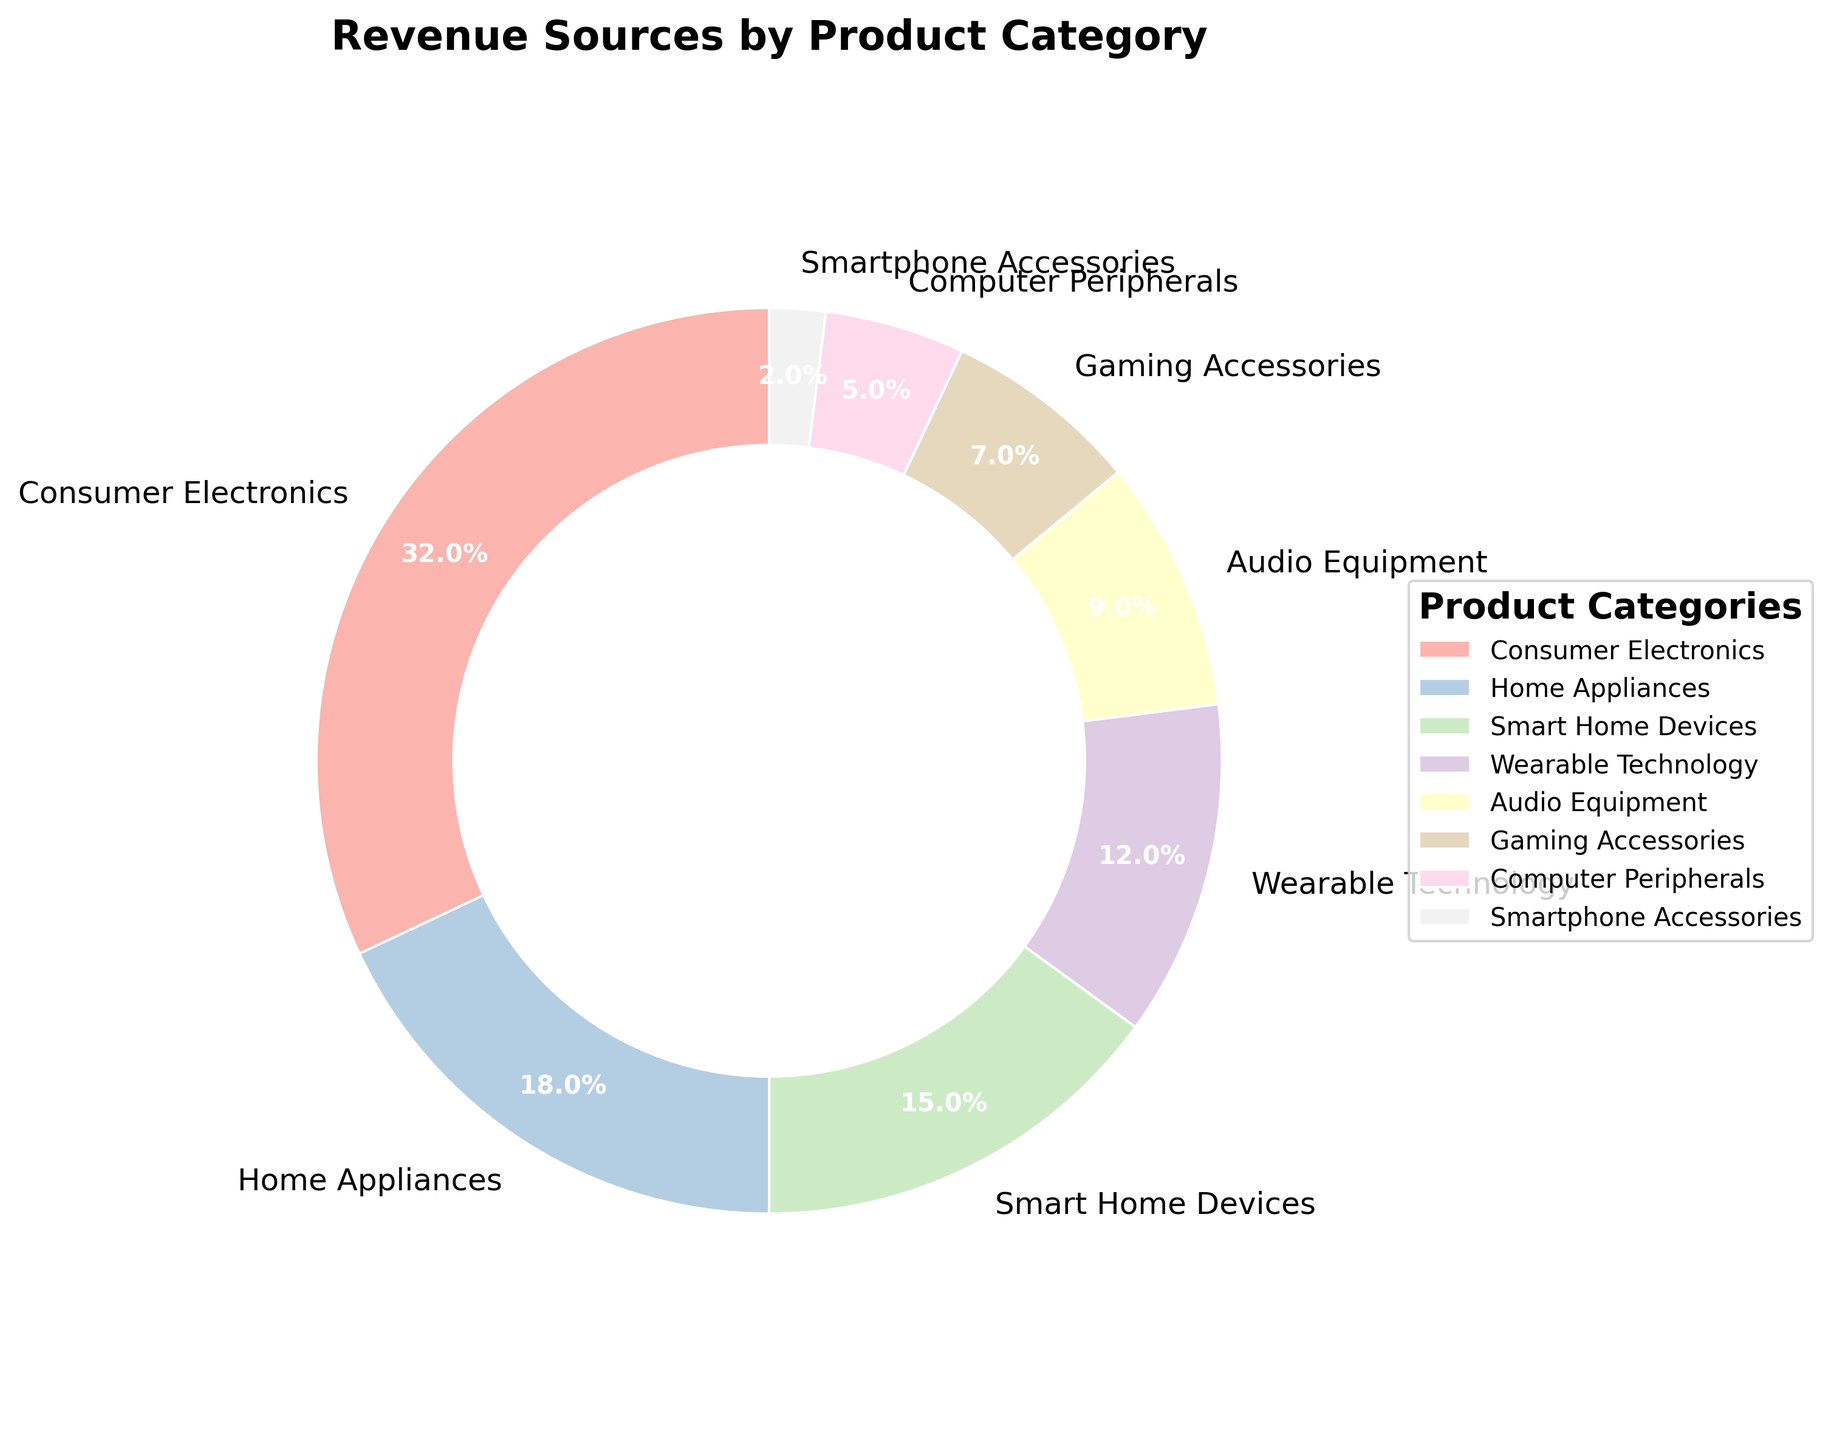Which product category generates the most revenue? The largest wedge in the pie chart represents the product category that generates the most revenue. By looking at the size of the wedges, Consumer Electronics is the largest.
Answer: Consumer Electronics What is the total percentage of revenue generated by Smart Home Devices and Wearable Technology? To find the total percentage, add the revenue percentages of Smart Home Devices (15%) and Wearable Technology (12%). 15% + 12% = 27%
Answer: 27% How does the revenue from Audio Equipment compare to that from Gaming Accessories? By examining the pie chart, Audio Equipment has a revenue percentage of 9% and Gaming Accessories has 7%. Since 9% is greater than 7%, Audio Equipment generates more revenue.
Answer: Audio Equipment generates more revenue Which product categories combined make up more than 50% of the total revenue? Summarizing the revenue percentages from the largest to smallest until the sum exceeds 50%: Consumer Electronics (32%), Home Appliances (18%), and Smart Home Devices (15%). 32% + 18% + 15% = 65%, which is more than 50%.
Answer: Consumer Electronics, Home Appliances, Smart Home Devices What is the difference in revenue percentage between the highest and lowest revenue-generating categories? Consumer Electronics generates the highest revenue at 32%, and Smartphone Accessories generate the lowest at 2%. The difference is calculated as 32% - 2% = 30%.
Answer: 30% Which product category generates the least revenue? The smallest wedge in the pie chart represents the product category that generates the least revenue. This is the Smartphone Accessories category with 2%.
Answer: Smartphone Accessories Are there more product categories generating at least 10% of the revenue or less than 10%? Counting the categories based on their revenue percentages: At least 10% - Consumer Electronics, Home Appliances, Smart Home Devices, and Wearable Technology (4 categories); Less than 10% - Audio Equipment, Gaming Accessories, Computer Peripherals, and Smartphone Accessories (4 categories). Both have an equal count.
Answer: Equal count What fraction of the total revenue does the Home Appliances category generate? The pie chart shows the Home Appliances category generates 18% of total revenue. In fraction form, this is 18/100, which simplifies to 9/50.
Answer: 9/50 How does the color of the Wearable Technology wedge compare to the Audio Equipment wedge? Observing the pie chart colors, Wearable Technology is represented by a pastel shade, and Audio Equipment by another distinct pastel shade within the same color scheme but different hues. Both are in different pastel colors.
Answer: Different pastel colors 